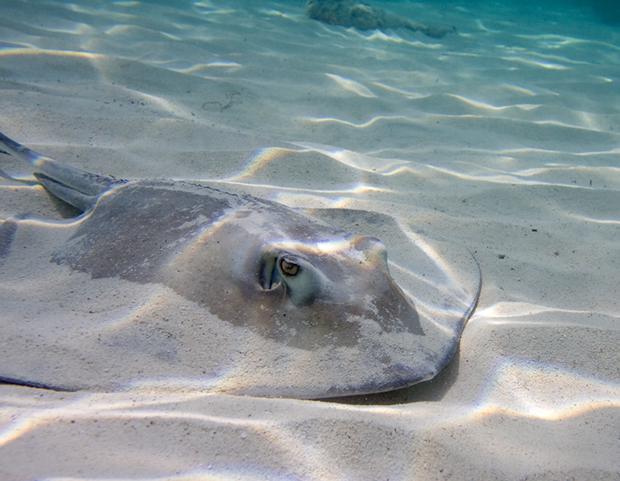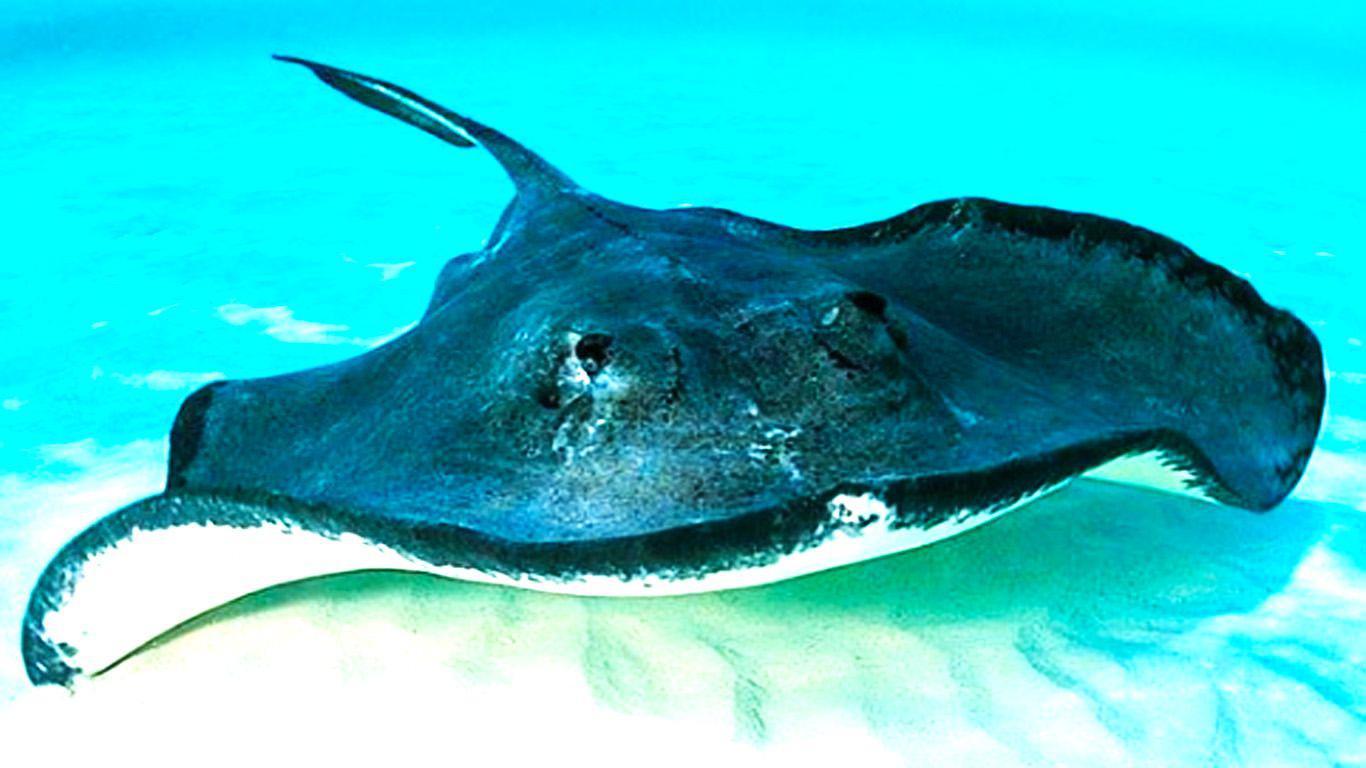The first image is the image on the left, the second image is the image on the right. Examine the images to the left and right. Is the description "The ocean floor is visible in both images." accurate? Answer yes or no. Yes. The first image is the image on the left, the second image is the image on the right. Assess this claim about the two images: "The left and right image contains the same number stingrays with at least one with blue dots.". Correct or not? Answer yes or no. No. 